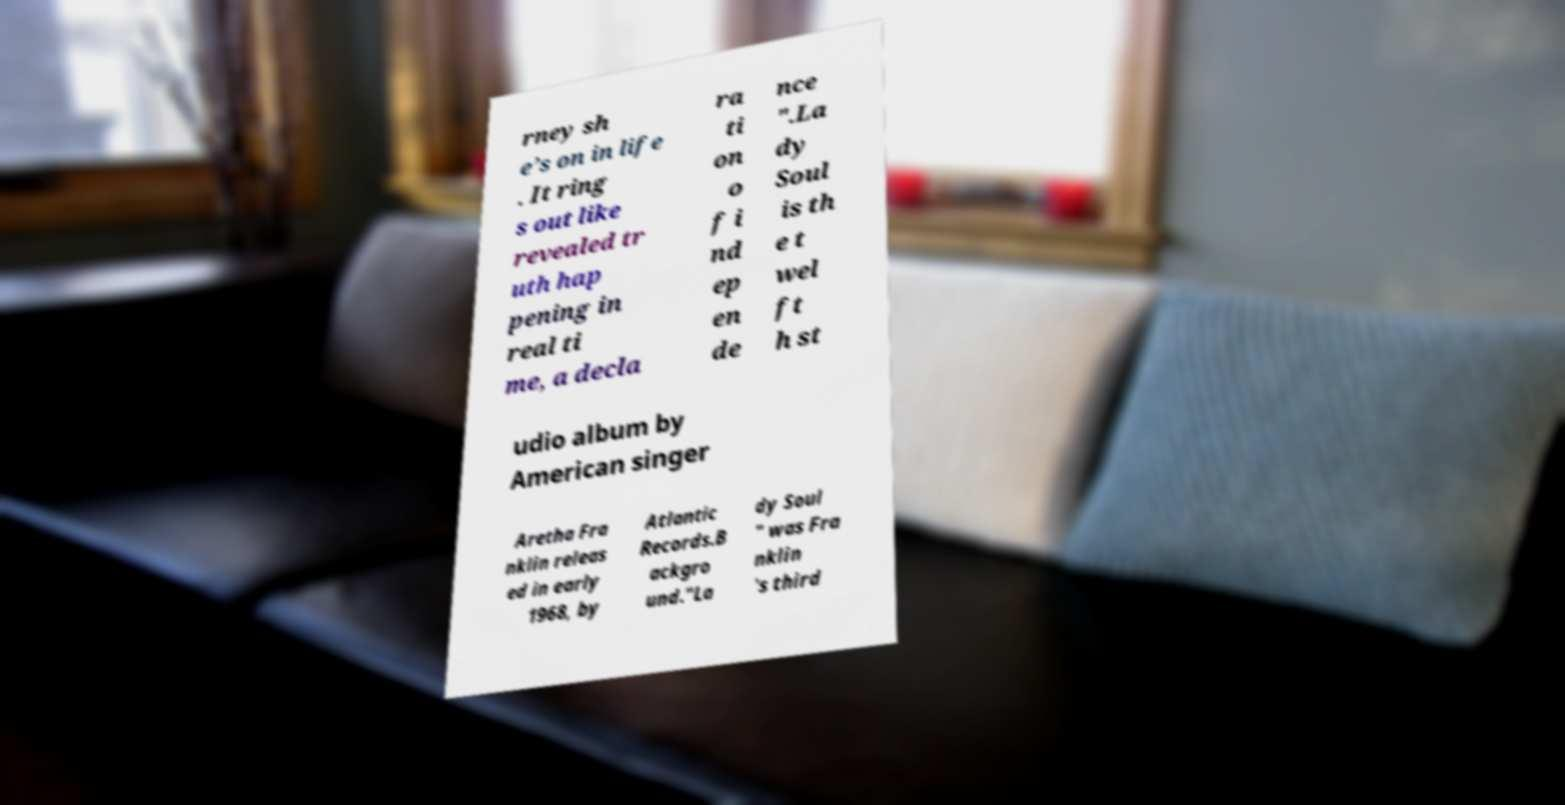Could you assist in decoding the text presented in this image and type it out clearly? rney sh e’s on in life . It ring s out like revealed tr uth hap pening in real ti me, a decla ra ti on o f i nd ep en de nce ".La dy Soul is th e t wel ft h st udio album by American singer Aretha Fra nklin releas ed in early 1968, by Atlantic Records.B ackgro und."La dy Soul " was Fra nklin 's third 